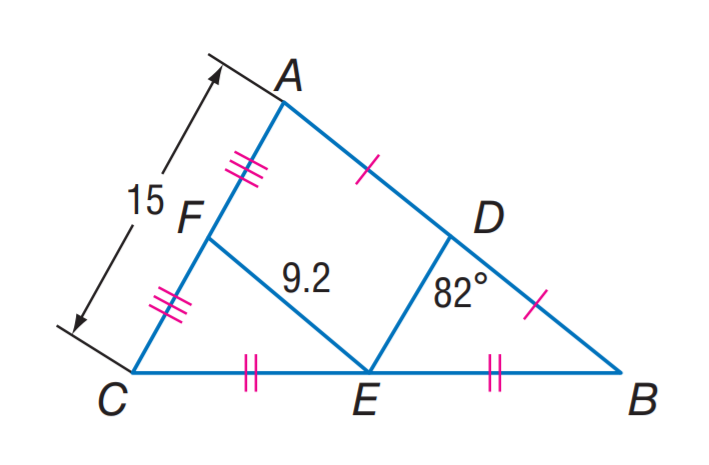Answer the mathemtical geometry problem and directly provide the correct option letter.
Question: Find D E.
Choices: A: 7.5 B: 9.2 C: 10 D: 18.4 A 